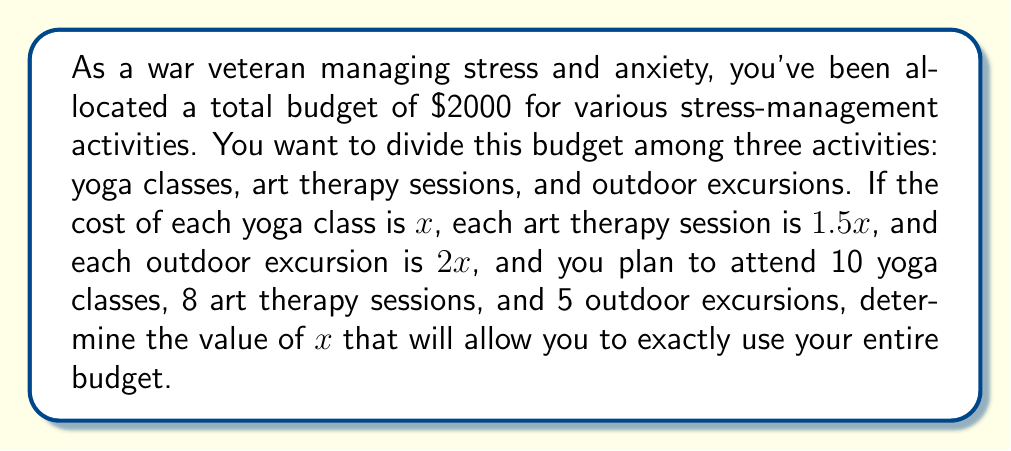Help me with this question. Let's approach this problem step by step:

1) First, let's set up an equation based on the given information:
   - Cost of yoga classes: $10x$ (10 classes at $x$ each)
   - Cost of art therapy sessions: $8(1.5x) = 12x$ (8 sessions at $1.5x$ each)
   - Cost of outdoor excursions: $5(2x) = 10x$ (5 excursions at $2x$ each)

2) The total cost should equal the budget of $2000. So we can write:

   $$10x + 12x + 10x = 2000$$

3) Simplify the left side of the equation:

   $$32x = 2000$$

4) Now, solve for $x$ by dividing both sides by 32:

   $$x = \frac{2000}{32} = 62.5$$

5) To verify, let's plug this value back into our original costs:
   - Yoga classes: $10(62.5) = 625$
   - Art therapy sessions: $12(62.5) = 750$
   - Outdoor excursions: $10(62.5) = 625$

   Total: $625 + 750 + 625 = 2000$

This confirms that our solution is correct and uses the entire budget.
Answer: $x = 62.5$ 